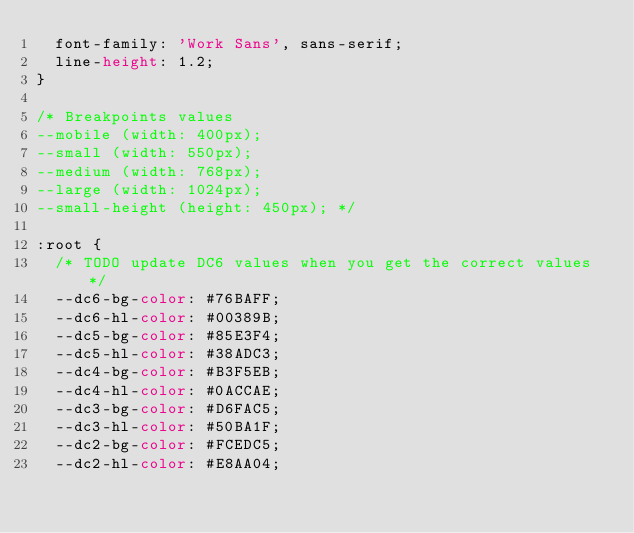<code> <loc_0><loc_0><loc_500><loc_500><_CSS_>  font-family: 'Work Sans', sans-serif;
  line-height: 1.2;
}

/* Breakpoints values
--mobile (width: 400px);
--small (width: 550px);
--medium (width: 768px);
--large (width: 1024px);
--small-height (height: 450px); */

:root {
  /* TODO update DC6 values when you get the correct values */
  --dc6-bg-color: #76BAFF;
  --dc6-hl-color: #00389B;
  --dc5-bg-color: #85E3F4;
  --dc5-hl-color: #38ADC3;
  --dc4-bg-color: #B3F5EB;
  --dc4-hl-color: #0ACCAE;
  --dc3-bg-color: #D6FAC5;
  --dc3-hl-color: #50BA1F;
  --dc2-bg-color: #FCEDC5;
  --dc2-hl-color: #E8AA04;</code> 